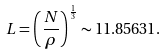<formula> <loc_0><loc_0><loc_500><loc_500>L = \left ( \frac { N } { \rho } \right ) ^ { \frac { 1 } { 3 } } \sim 1 1 . 8 5 6 3 1 .</formula> 